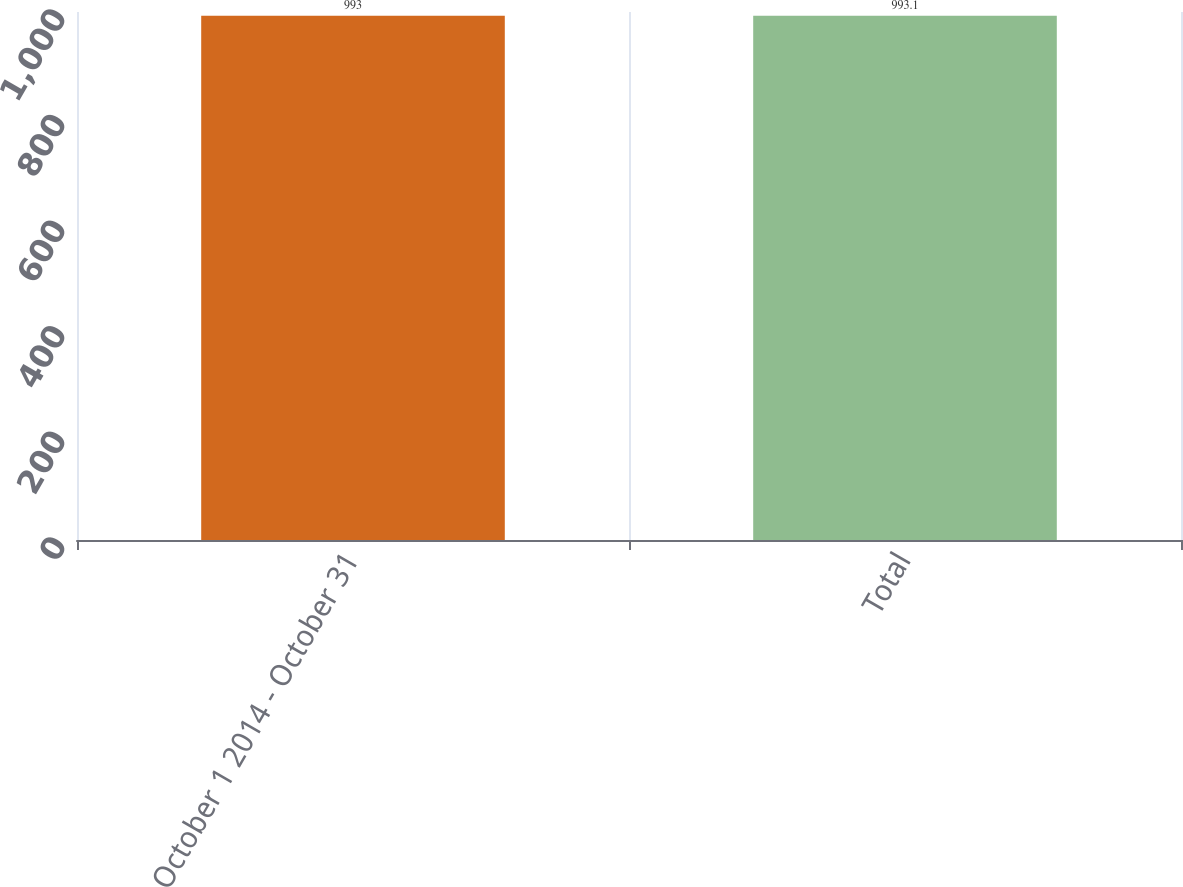Convert chart. <chart><loc_0><loc_0><loc_500><loc_500><bar_chart><fcel>October 1 2014 - October 31<fcel>Total<nl><fcel>993<fcel>993.1<nl></chart> 